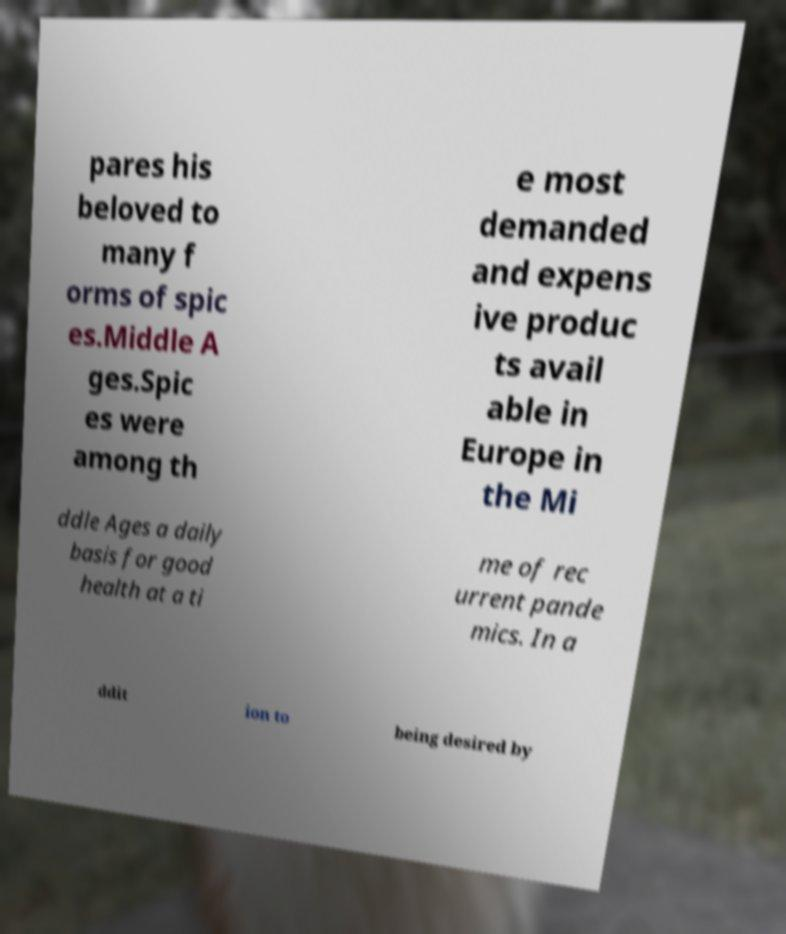For documentation purposes, I need the text within this image transcribed. Could you provide that? pares his beloved to many f orms of spic es.Middle A ges.Spic es were among th e most demanded and expens ive produc ts avail able in Europe in the Mi ddle Ages a daily basis for good health at a ti me of rec urrent pande mics. In a ddit ion to being desired by 